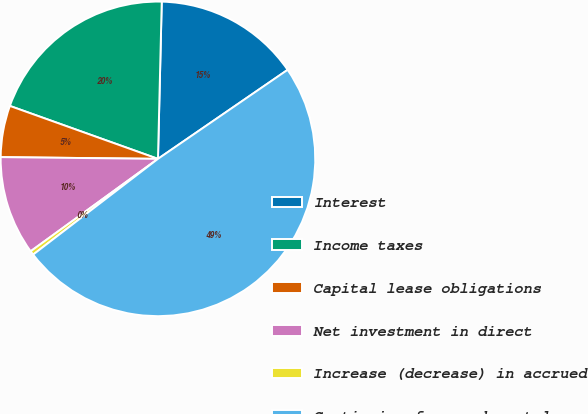<chart> <loc_0><loc_0><loc_500><loc_500><pie_chart><fcel>Interest<fcel>Income taxes<fcel>Capital lease obligations<fcel>Net investment in direct<fcel>Increase (decrease) in accrued<fcel>Continuing fees and rental<nl><fcel>15.04%<fcel>19.92%<fcel>5.29%<fcel>10.17%<fcel>0.42%<fcel>49.17%<nl></chart> 